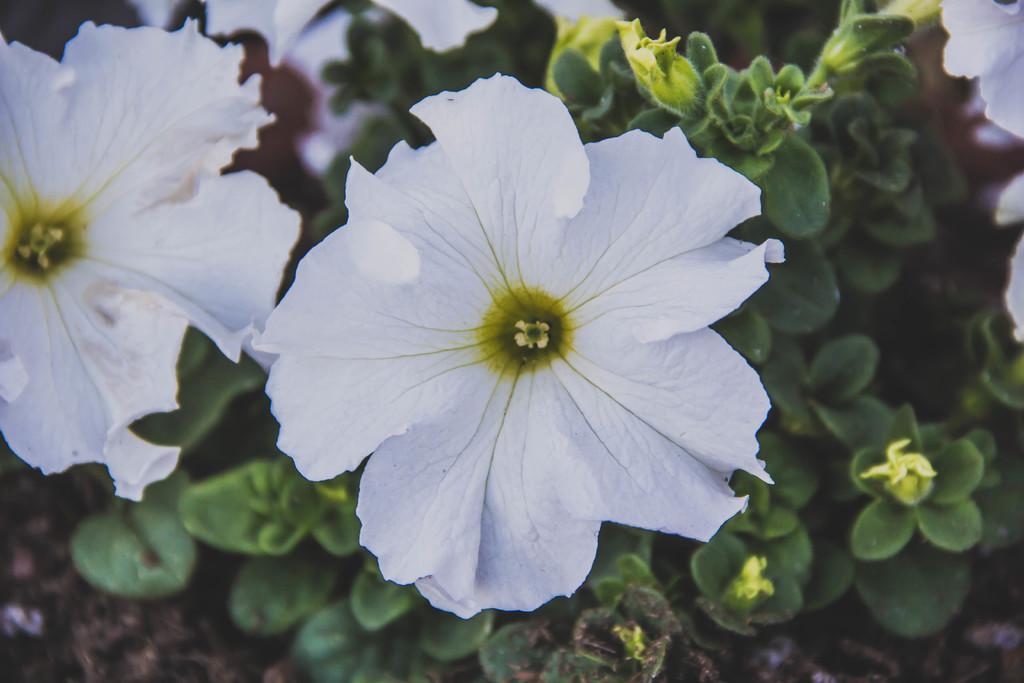Describe this image in one or two sentences. In this picture we can observe white color flowers. In the background there are green color plants on the ground. 